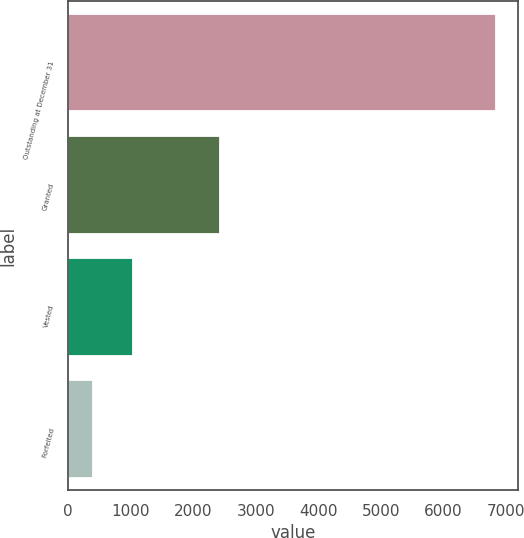<chart> <loc_0><loc_0><loc_500><loc_500><bar_chart><fcel>Outstanding at December 31<fcel>Granted<fcel>Vested<fcel>Forfeited<nl><fcel>6846.4<fcel>2427<fcel>1036.4<fcel>389<nl></chart> 